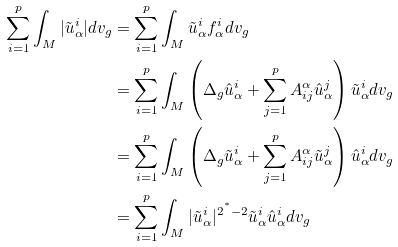<formula> <loc_0><loc_0><loc_500><loc_500>\sum _ { i = 1 } ^ { p } \int _ { M } | \tilde { u } _ { \alpha } ^ { i } | d v _ { g } & = \sum _ { i = 1 } ^ { p } \int _ { M } \tilde { u } _ { \alpha } ^ { i } f _ { \alpha } ^ { i } d v _ { g } \\ & = \sum _ { i = 1 } ^ { p } \int _ { M } \left ( \Delta _ { g } \hat { u } _ { \alpha } ^ { i } + \sum _ { j = 1 } ^ { p } A ^ { \alpha } _ { i j } \hat { u } _ { \alpha } ^ { j } \right ) \tilde { u } _ { \alpha } ^ { i } d v _ { g } \\ & = \sum _ { i = 1 } ^ { p } \int _ { M } \left ( \Delta _ { g } \tilde { u } _ { \alpha } ^ { i } + \sum _ { j = 1 } ^ { p } A ^ { \alpha } _ { i j } \tilde { u } _ { \alpha } ^ { j } \right ) \hat { u } _ { \alpha } ^ { i } d v _ { g } \\ & = \sum _ { i = 1 } ^ { p } \int _ { M } | \tilde { u } _ { \alpha } ^ { i } | ^ { 2 ^ { ^ { * } } - 2 } \tilde { u } _ { \alpha } ^ { i } \hat { u } _ { \alpha } ^ { i } d v _ { g } \\</formula> 